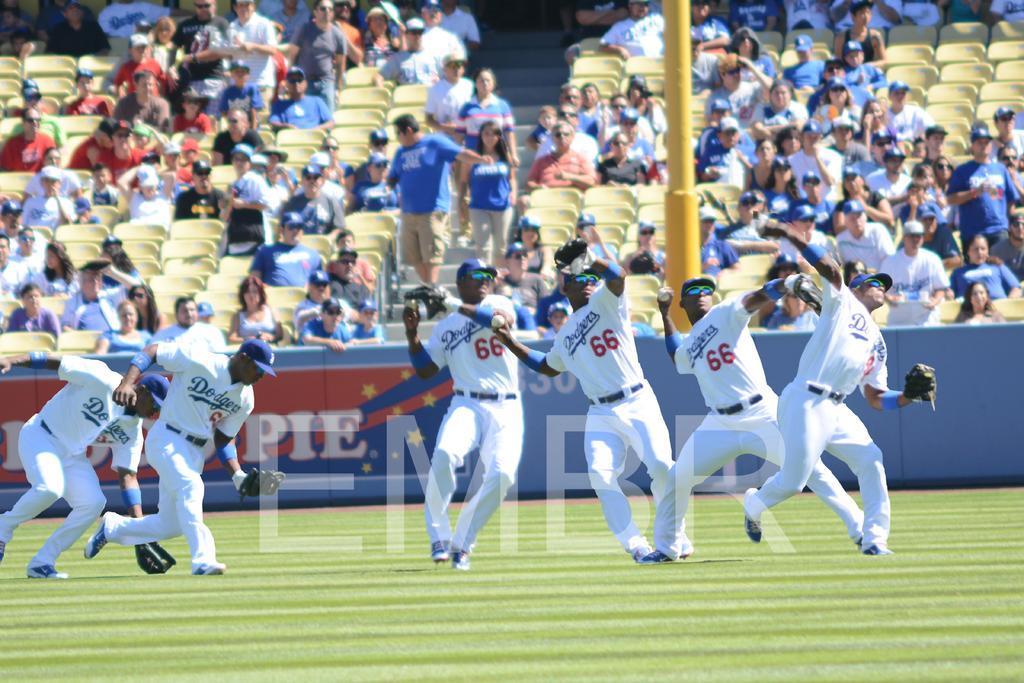Could you give a brief overview of what you see in this image? In this there is a playground, there is grass, the players are playing on the ground, there is a board, there is text on the board, there is a pole truncated, there are cars, there are audience, there is a staircase, there are persons truncated towards the right of the image, there are persons truncated towards the left of the image. 